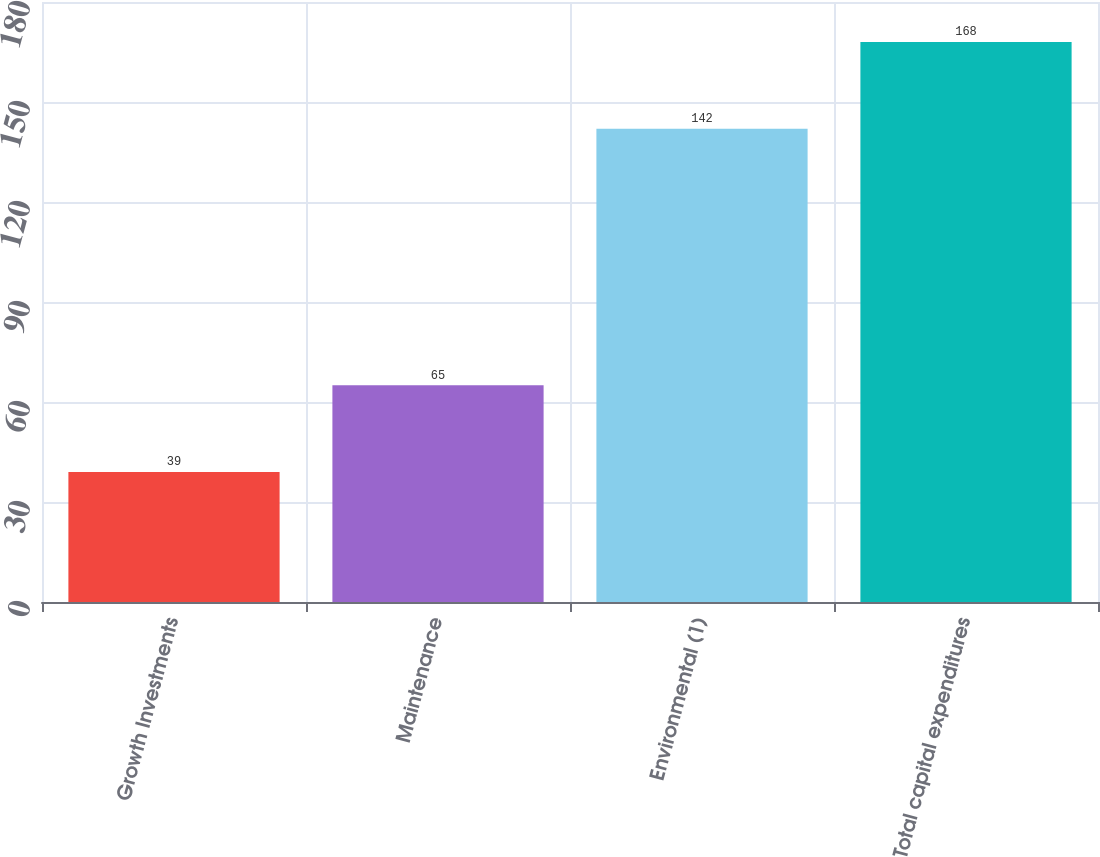Convert chart to OTSL. <chart><loc_0><loc_0><loc_500><loc_500><bar_chart><fcel>Growth Investments<fcel>Maintenance<fcel>Environmental (1)<fcel>Total capital expenditures<nl><fcel>39<fcel>65<fcel>142<fcel>168<nl></chart> 